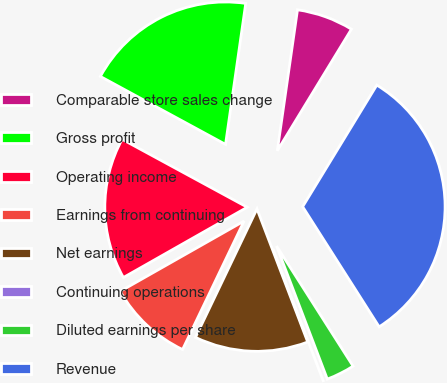<chart> <loc_0><loc_0><loc_500><loc_500><pie_chart><fcel>Comparable store sales change<fcel>Gross profit<fcel>Operating income<fcel>Earnings from continuing<fcel>Net earnings<fcel>Continuing operations<fcel>Diluted earnings per share<fcel>Revenue<nl><fcel>6.45%<fcel>19.35%<fcel>16.13%<fcel>9.68%<fcel>12.9%<fcel>0.0%<fcel>3.23%<fcel>32.26%<nl></chart> 